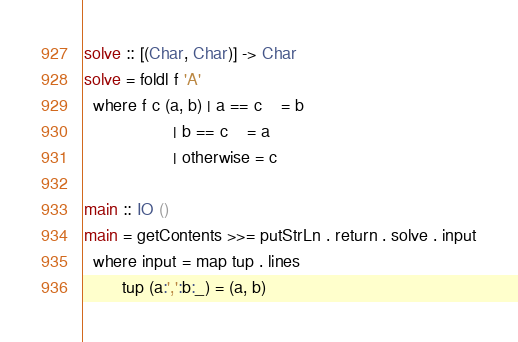<code> <loc_0><loc_0><loc_500><loc_500><_Haskell_>solve :: [(Char, Char)] -> Char
solve = foldl f 'A'
  where f c (a, b) | a == c    = b
                   | b == c    = a
                   | otherwise = c

main :: IO ()
main = getContents >>= putStrLn . return . solve . input
  where input = map tup . lines
        tup (a:',':b:_) = (a, b)</code> 